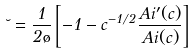<formula> <loc_0><loc_0><loc_500><loc_500>\lambda = \frac { 1 } { 2 \tau } \left [ - 1 - c ^ { - 1 / 2 } \frac { A i ^ { \prime } ( c ) } { A i ( c ) } \right ]</formula> 